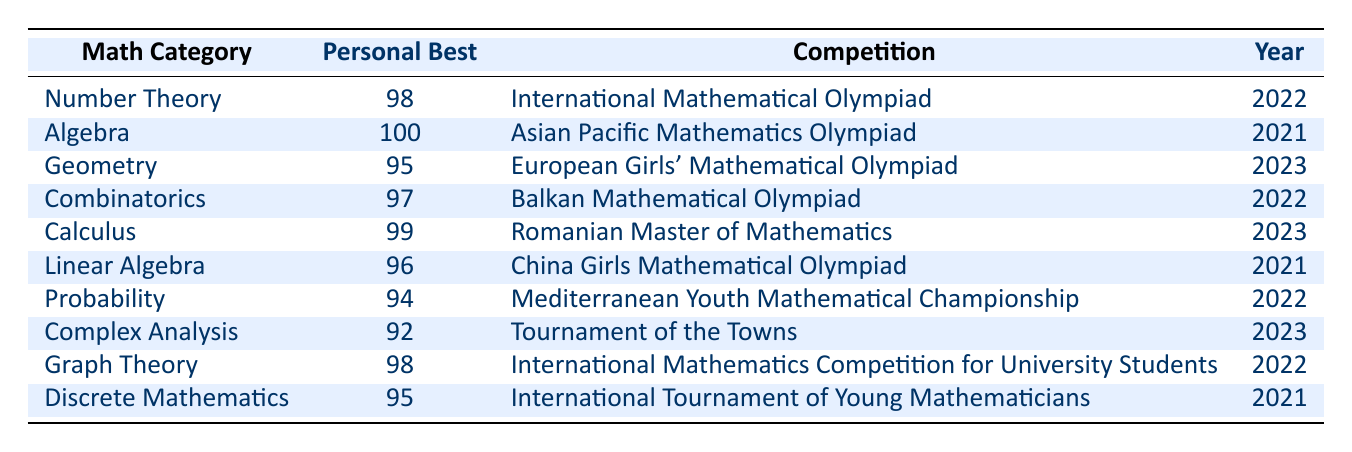What is the personal best score in Algebra? From the table, we can look in the row corresponding to Algebra. The personal best score listed there is 100.
Answer: 100 Which competition had the highest personal best score? We need to review all the personal best scores provided in the table. The highest score is 100 in the Algebra category, which occurred at the Asian Pacific Mathematics Olympiad.
Answer: Asian Pacific Mathematics Olympiad How many competitions were held in the year 2022? We count the number of rows in the table where the year is 2022. There are four competitions listed: International Mathematical Olympiad, Balkan Mathematical Olympiad, Mediterranean Youth Mathematical Championship, and International Mathematics Competition for University Students.
Answer: 4 What is the average personal best score for the categories that took place in 2023? The personal best scores for the years 2023 are 95 in Geometry and 99 in Calculus. Adding these scores gives us 95 + 99 = 194. There are 2 categories, so the average score is 194 / 2 = 97.
Answer: 97 Is the personal best score in Probability higher than 90? We can check the score listed for Probability, which is 94. Since 94 is greater than 90, the statement is true.
Answer: Yes Which two math categories had personal best scores that were equal? Checking the scores, we see that Number Theory and Graph Theory both have personal best scores of 98.
Answer: Number Theory and Graph Theory What is the difference between the highest and lowest personal best scores? The highest personal best score is 100 (in Algebra), and the lowest is 92 (in Complex Analysis). The difference is 100 - 92 = 8.
Answer: 8 Did any competition have a personal best score of 96? Looking through the table, we find that Linear Algebra’s personal best score is 96. Therefore, the statement is true.
Answer: Yes 